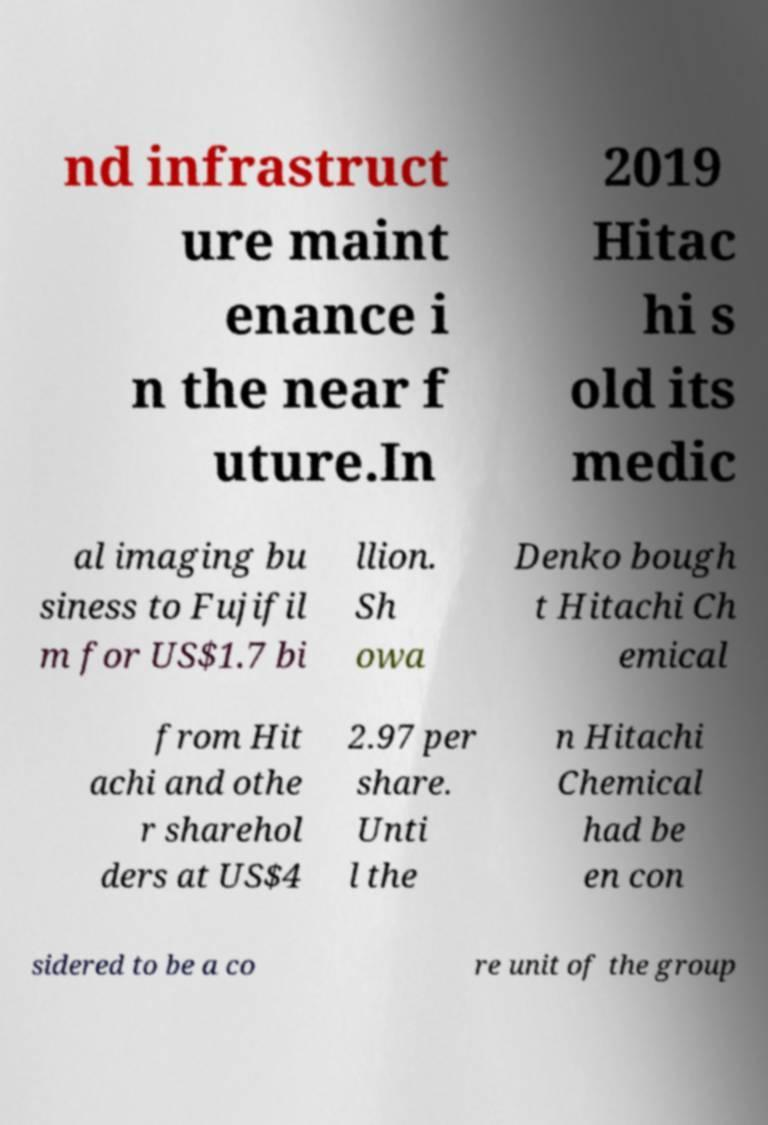Can you read and provide the text displayed in the image?This photo seems to have some interesting text. Can you extract and type it out for me? nd infrastruct ure maint enance i n the near f uture.In 2019 Hitac hi s old its medic al imaging bu siness to Fujifil m for US$1.7 bi llion. Sh owa Denko bough t Hitachi Ch emical from Hit achi and othe r sharehol ders at US$4 2.97 per share. Unti l the n Hitachi Chemical had be en con sidered to be a co re unit of the group 